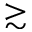Convert formula to latex. <formula><loc_0><loc_0><loc_500><loc_500>\gtrsim</formula> 